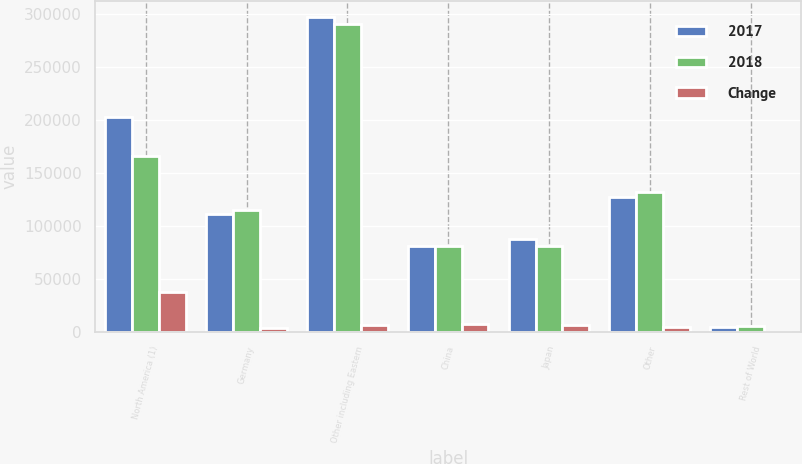<chart> <loc_0><loc_0><loc_500><loc_500><stacked_bar_chart><ecel><fcel>North America (1)<fcel>Germany<fcel>Other including Eastern<fcel>China<fcel>Japan<fcel>Other<fcel>Rest of World<nl><fcel>2017<fcel>202743<fcel>111259<fcel>296917<fcel>80612<fcel>87619<fcel>127251<fcel>5006<nl><fcel>2018<fcel>165363<fcel>114608<fcel>290067<fcel>80612<fcel>80612<fcel>131511<fcel>5445<nl><fcel>Change<fcel>37380<fcel>3349<fcel>6850<fcel>7796<fcel>7007<fcel>4260<fcel>439<nl></chart> 